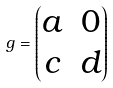Convert formula to latex. <formula><loc_0><loc_0><loc_500><loc_500>g = \begin{pmatrix} a & 0 \\ c & d \\ \end{pmatrix}</formula> 